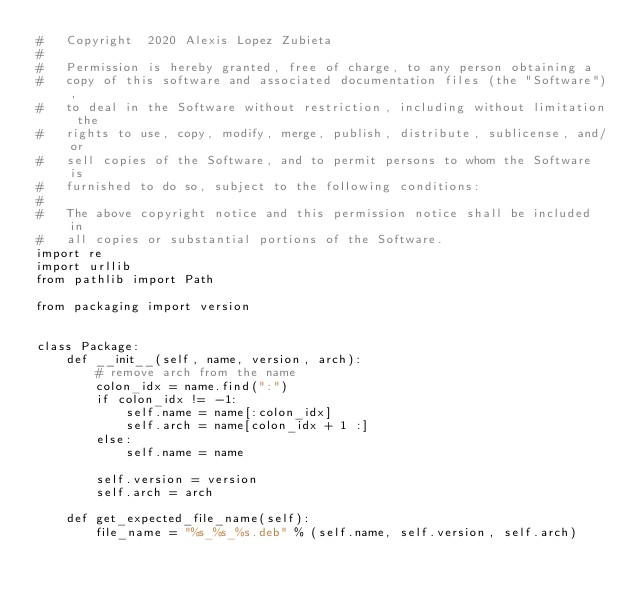<code> <loc_0><loc_0><loc_500><loc_500><_Python_>#   Copyright  2020 Alexis Lopez Zubieta
#
#   Permission is hereby granted, free of charge, to any person obtaining a
#   copy of this software and associated documentation files (the "Software"),
#   to deal in the Software without restriction, including without limitation the
#   rights to use, copy, modify, merge, publish, distribute, sublicense, and/or
#   sell copies of the Software, and to permit persons to whom the Software is
#   furnished to do so, subject to the following conditions:
#
#   The above copyright notice and this permission notice shall be included in
#   all copies or substantial portions of the Software.
import re
import urllib
from pathlib import Path

from packaging import version


class Package:
    def __init__(self, name, version, arch):
        # remove arch from the name
        colon_idx = name.find(":")
        if colon_idx != -1:
            self.name = name[:colon_idx]
            self.arch = name[colon_idx + 1 :]
        else:
            self.name = name

        self.version = version
        self.arch = arch

    def get_expected_file_name(self):
        file_name = "%s_%s_%s.deb" % (self.name, self.version, self.arch)
</code> 